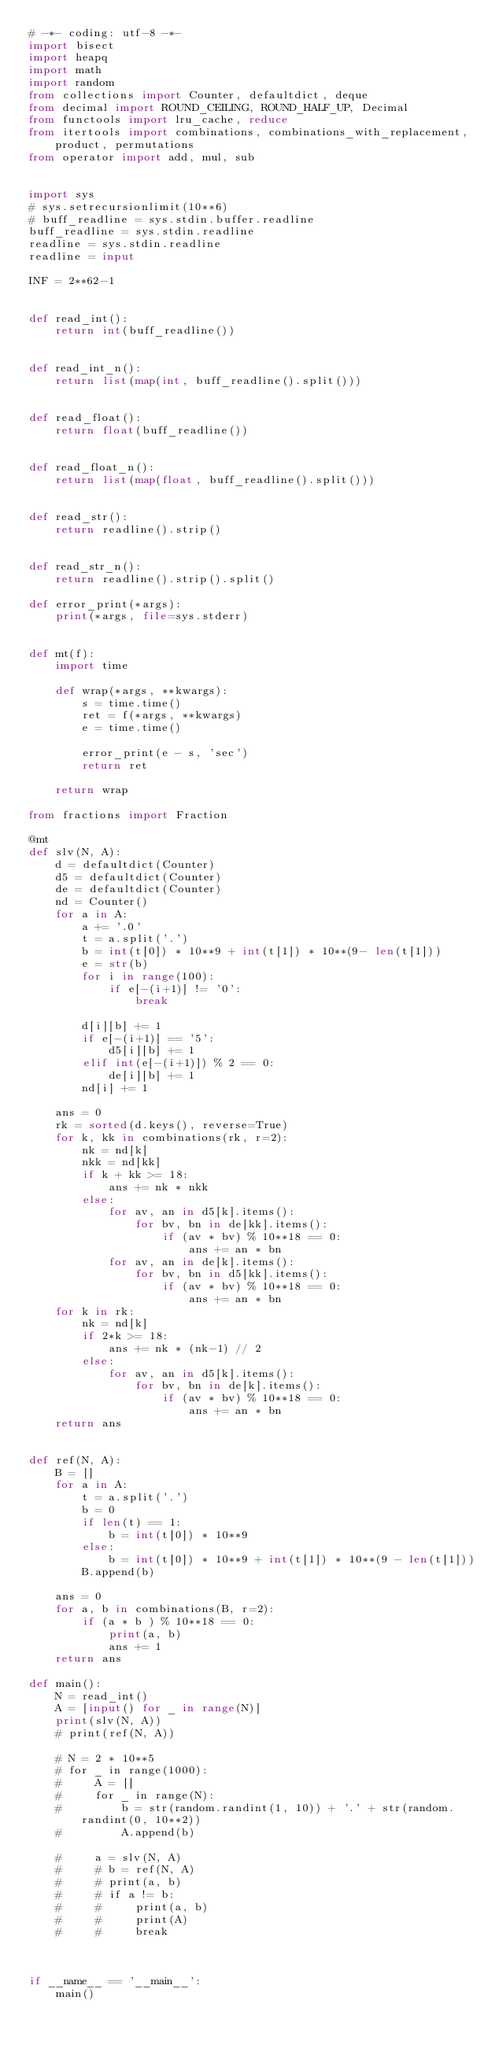Convert code to text. <code><loc_0><loc_0><loc_500><loc_500><_Python_># -*- coding: utf-8 -*-
import bisect
import heapq
import math
import random
from collections import Counter, defaultdict, deque
from decimal import ROUND_CEILING, ROUND_HALF_UP, Decimal
from functools import lru_cache, reduce
from itertools import combinations, combinations_with_replacement, product, permutations
from operator import add, mul, sub


import sys
# sys.setrecursionlimit(10**6)
# buff_readline = sys.stdin.buffer.readline
buff_readline = sys.stdin.readline
readline = sys.stdin.readline
readline = input

INF = 2**62-1


def read_int():
    return int(buff_readline())


def read_int_n():
    return list(map(int, buff_readline().split()))


def read_float():
    return float(buff_readline())


def read_float_n():
    return list(map(float, buff_readline().split()))


def read_str():
    return readline().strip()


def read_str_n():
    return readline().strip().split()

def error_print(*args):
    print(*args, file=sys.stderr)


def mt(f):
    import time

    def wrap(*args, **kwargs):
        s = time.time()
        ret = f(*args, **kwargs)
        e = time.time()

        error_print(e - s, 'sec')
        return ret

    return wrap

from fractions import Fraction

@mt
def slv(N, A):
    d = defaultdict(Counter)
    d5 = defaultdict(Counter)
    de = defaultdict(Counter)
    nd = Counter()
    for a in A:
        a += '.0'
        t = a.split('.')
        b = int(t[0]) * 10**9 + int(t[1]) * 10**(9- len(t[1]))
        e = str(b)
        for i in range(100):
            if e[-(i+1)] != '0':
                break

        d[i][b] += 1
        if e[-(i+1)] == '5':
            d5[i][b] += 1
        elif int(e[-(i+1)]) % 2 == 0:
            de[i][b] += 1
        nd[i] += 1

    ans = 0
    rk = sorted(d.keys(), reverse=True)
    for k, kk in combinations(rk, r=2):
        nk = nd[k]
        nkk = nd[kk]
        if k + kk >= 18:
            ans += nk * nkk
        else:
            for av, an in d5[k].items():
                for bv, bn in de[kk].items():
                    if (av * bv) % 10**18 == 0:
                        ans += an * bn
            for av, an in de[k].items():
                for bv, bn in d5[kk].items():
                    if (av * bv) % 10**18 == 0:
                        ans += an * bn
    for k in rk:
        nk = nd[k]
        if 2*k >= 18:
            ans += nk * (nk-1) // 2
        else:
            for av, an in d5[k].items():
                for bv, bn in de[k].items():
                    if (av * bv) % 10**18 == 0:
                        ans += an * bn
    return ans


def ref(N, A):
    B = []
    for a in A:
        t = a.split('.')
        b = 0
        if len(t) == 1:
            b = int(t[0]) * 10**9
        else:
            b = int(t[0]) * 10**9 + int(t[1]) * 10**(9 - len(t[1]))
        B.append(b)

    ans = 0
    for a, b in combinations(B, r=2):
        if (a * b ) % 10**18 == 0:
            print(a, b)
            ans += 1
    return ans

def main():
    N = read_int()
    A = [input() for _ in range(N)]
    print(slv(N, A))
    # print(ref(N, A))

    # N = 2 * 10**5
    # for _ in range(1000):
    #     A = []
    #     for _ in range(N):
    #         b = str(random.randint(1, 10)) + '.' + str(random.randint(0, 10**2))
    #         A.append(b)

    #     a = slv(N, A)
    #     # b = ref(N, A)
    #     # print(a, b)
    #     # if a != b:
    #     #     print(a, b)
    #     #     print(A)
    #     #     break



if __name__ == '__main__':
    main()
</code> 